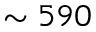<formula> <loc_0><loc_0><loc_500><loc_500>\sim 5 9 0</formula> 